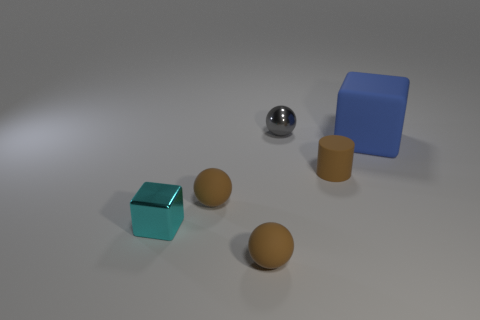Subtract all small brown spheres. How many spheres are left? 1 Add 2 small rubber things. How many objects exist? 8 Subtract all blue blocks. How many brown balls are left? 2 Subtract all gray spheres. How many spheres are left? 2 Subtract 1 balls. How many balls are left? 2 Subtract all blocks. How many objects are left? 4 Add 2 brown cylinders. How many brown cylinders are left? 3 Add 6 small blue metal spheres. How many small blue metal spheres exist? 6 Subtract 0 purple cylinders. How many objects are left? 6 Subtract all gray cylinders. Subtract all gray spheres. How many cylinders are left? 1 